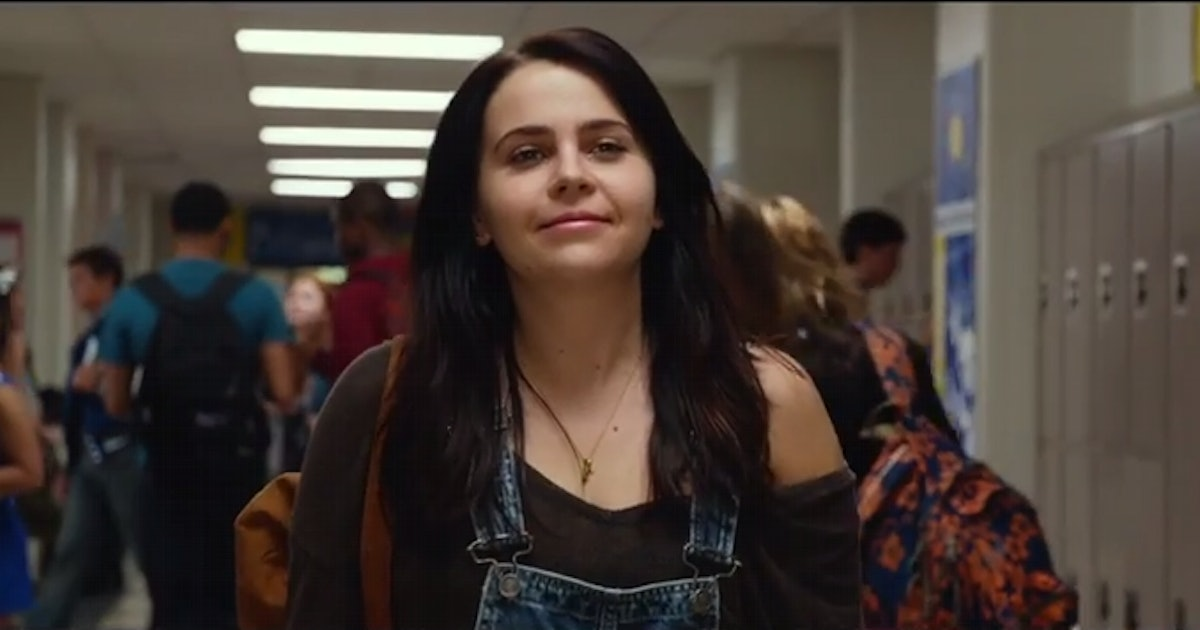Imagine a storyline for this character. What might be happening in her life? Imagine this character, Emily, is navigating her way through the challenges of high school. With a keen sense of curiosity and a thirst for adventure, she’s recently joined the school’s journalism club, determined to uncover the hidden stories within the school walls. Today, she's excited about her first major assignment: interviewing a mysterious new student who seems to have an enigmatic past. As she walks through the halls, her mind is racing with questions and angles for her story, setting off a chain of events that will lead her into a deeper investigation than she ever imagined. That sounds fascinating! What happens next in her story? Emily's determination leads her to the new student's locker, where she finds a cryptic note tucked into the lock. The note contains a riddle hinting at a secret meeting spot known only to a few alumni. Intrigued yet cautious, Emily decides to follow the clues, which take her to a hidden room in the old part of the school. There she meets not just the new student but also a small, secretive group committed to preserving the school's forgotten history. As she delves deeper into their world, Emily discovers that the school holds secrets dating back generations, some of which could change the course of the students' futures. She must now decide whether to report her findings or help protect the legacy her new friends are so passionate about. 